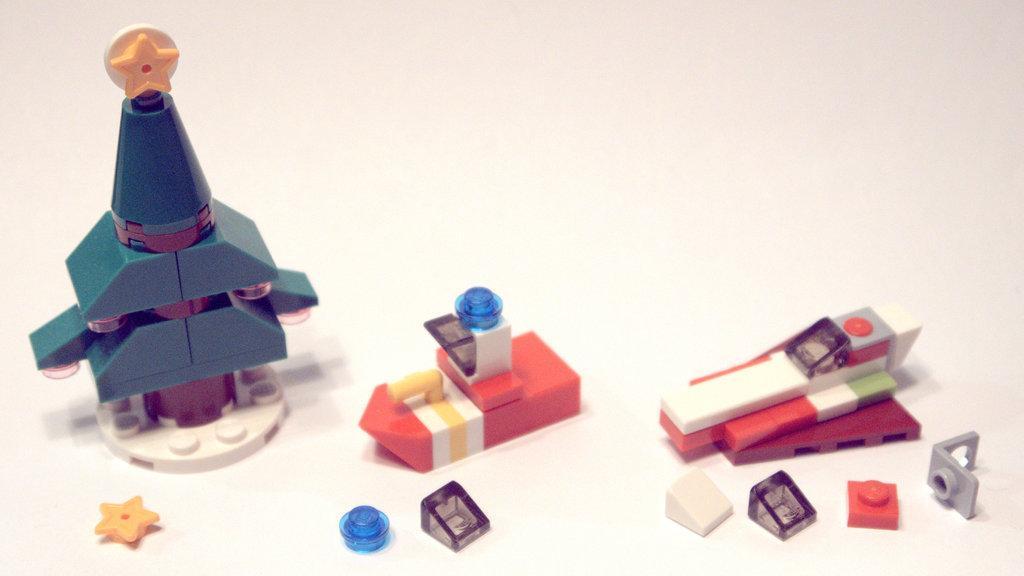Describe this image in one or two sentences. In this image there are some objects on the floor. 